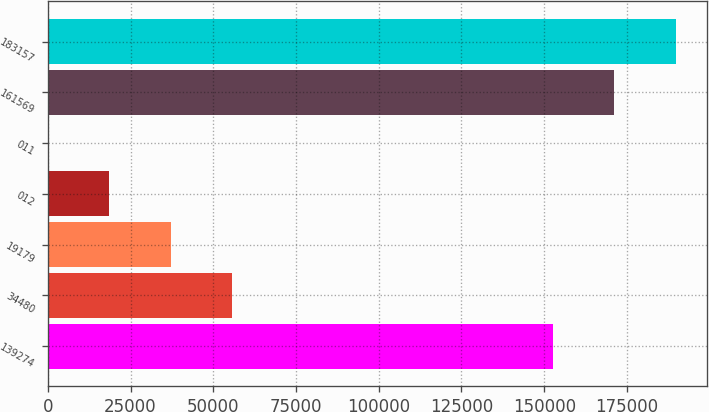<chart> <loc_0><loc_0><loc_500><loc_500><bar_chart><fcel>139274<fcel>34480<fcel>19179<fcel>012<fcel>011<fcel>161569<fcel>183157<nl><fcel>152654<fcel>55680.4<fcel>37120.3<fcel>18560.2<fcel>0.12<fcel>171214<fcel>189774<nl></chart> 